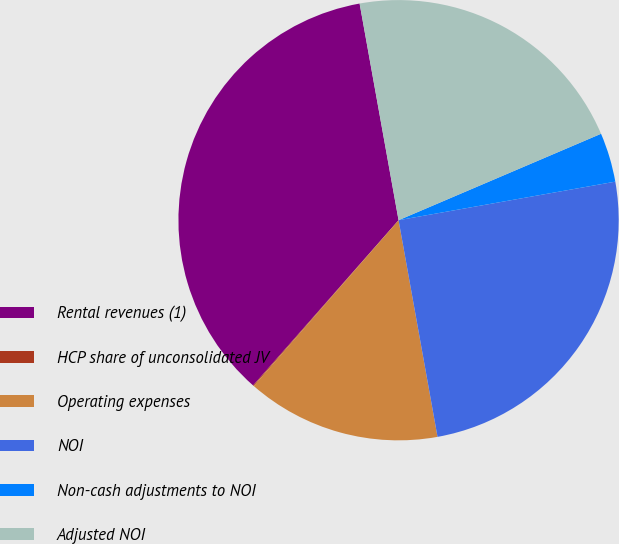Convert chart to OTSL. <chart><loc_0><loc_0><loc_500><loc_500><pie_chart><fcel>Rental revenues (1)<fcel>HCP share of unconsolidated JV<fcel>Operating expenses<fcel>NOI<fcel>Non-cash adjustments to NOI<fcel>Adjusted NOI<nl><fcel>35.68%<fcel>0.06%<fcel>14.26%<fcel>24.97%<fcel>3.62%<fcel>21.41%<nl></chart> 